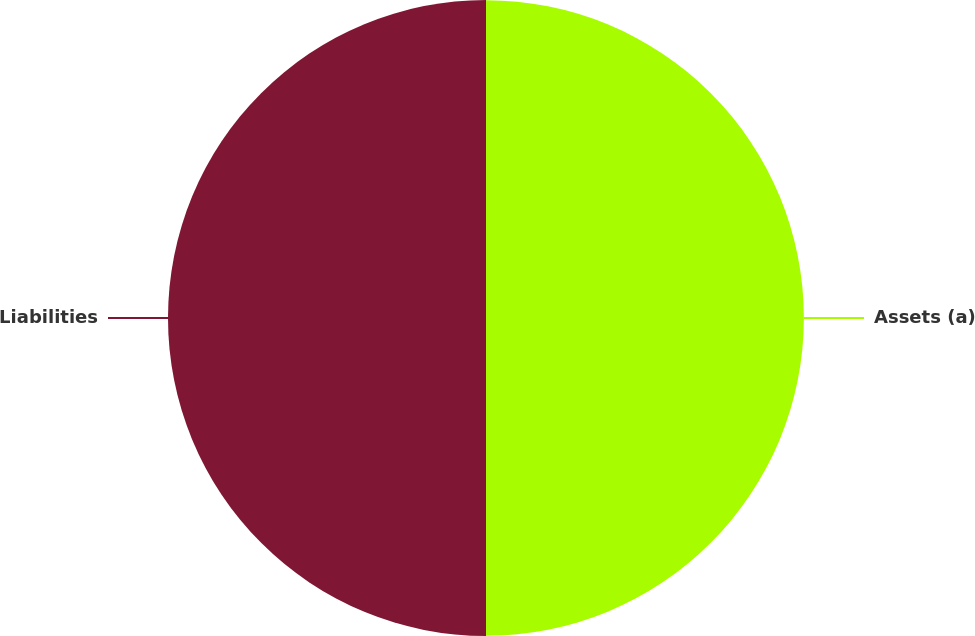<chart> <loc_0><loc_0><loc_500><loc_500><pie_chart><fcel>Assets (a)<fcel>Liabilities<nl><fcel>49.99%<fcel>50.01%<nl></chart> 